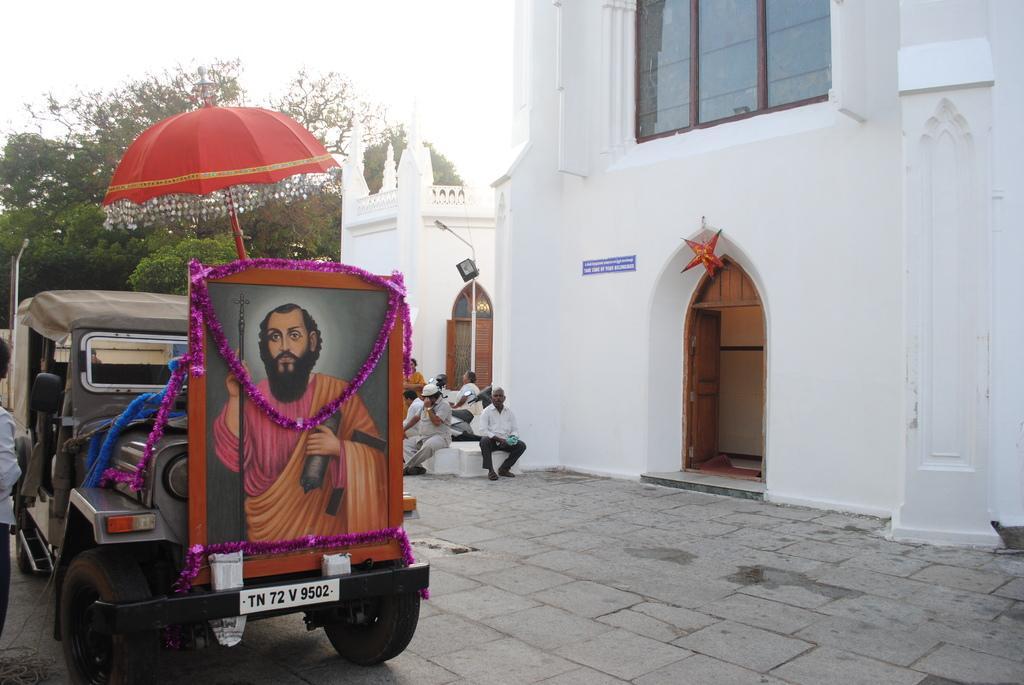In one or two sentences, can you explain what this image depicts? In this image I can see a vehicle which is ash in color and a photo frame attached to the vehicle and I can see an umbrella which is orange in color above the photo frame. To the left side of the image I can see a person standing. In the background I can see number of people sitting, a white colored building, the window, few trees and the sky. 